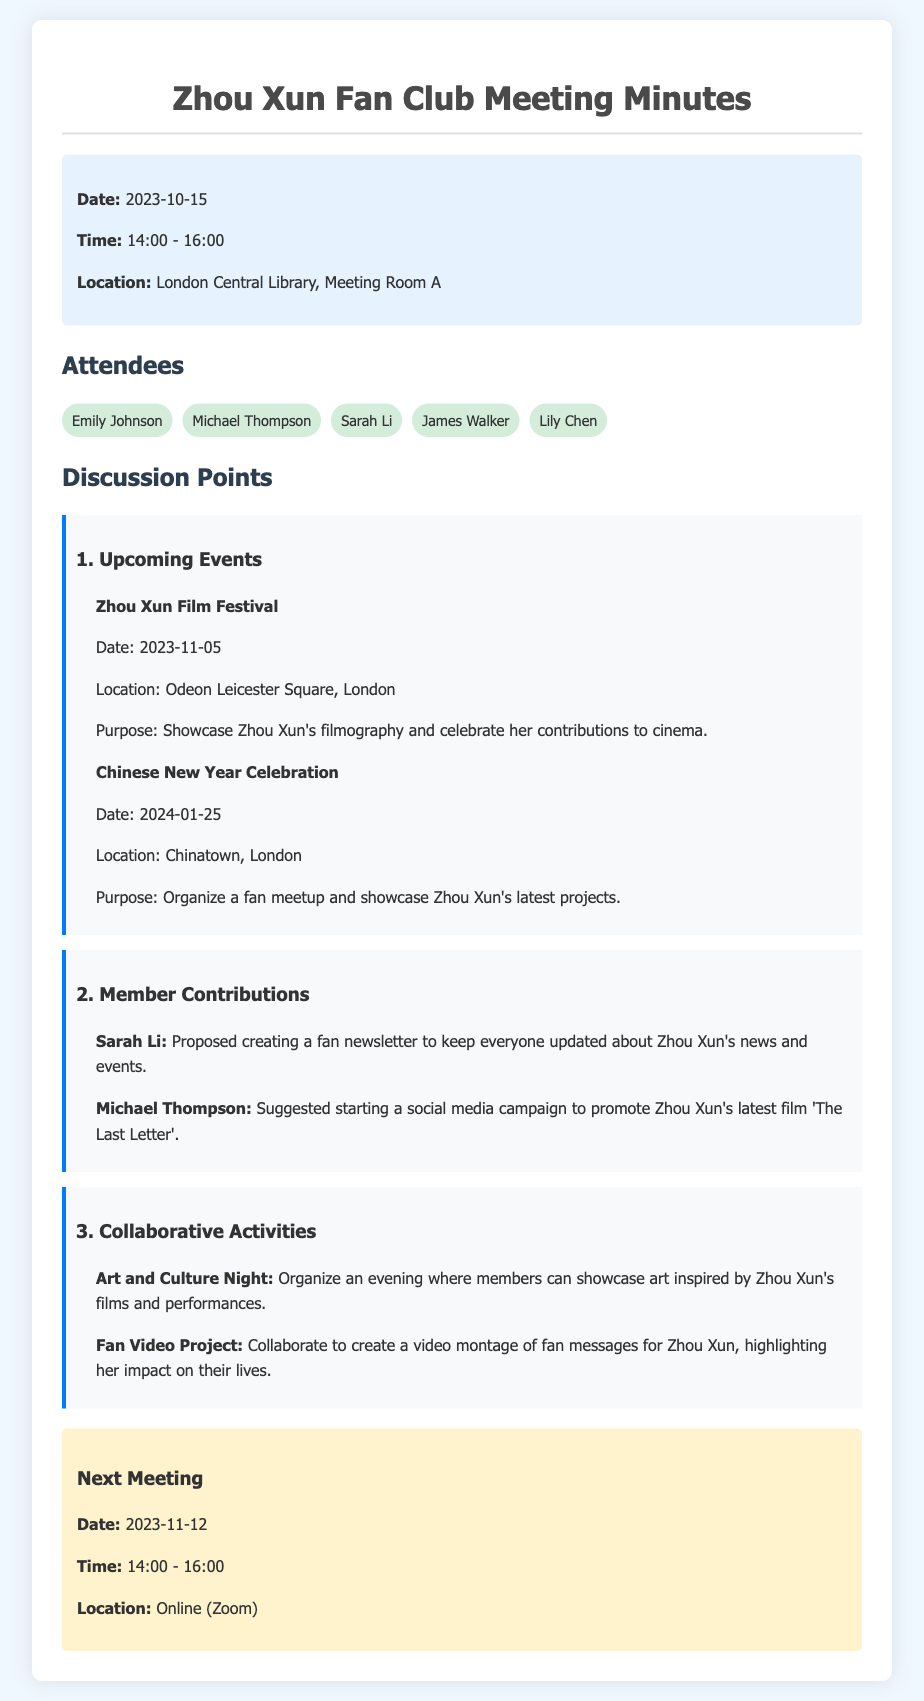what is the date of the Zhou Xun Film Festival? The date of the Zhou Xun Film Festival is mentioned as 2023-11-05 in the document.
Answer: 2023-11-05 where is the next meeting scheduled to take place? The location of the next meeting, which is on 2023-11-12, is specified as Online (Zoom).
Answer: Online (Zoom) who proposed creating a fan newsletter? The document states that Sarah Li proposed creating a fan newsletter.
Answer: Sarah Li what collaborative activity is about creating a video montage? The activity that involves creating a video montage is called the Fan Video Project, as mentioned in the discussion points.
Answer: Fan Video Project how many attendees were present at the meeting? The document lists five attendees present at the meeting.
Answer: 5 what is the purpose of the Chinese New Year Celebration? The purpose of the Chinese New Year Celebration is to organize a fan meetup and showcase Zhou Xun’s latest projects.
Answer: Organize a fan meetup and showcase Zhou Xun’s latest projects which member suggested a social media campaign? The document indicates that Michael Thompson suggested starting a social media campaign.
Answer: Michael Thompson when is the Chinese New Year Celebration scheduled? The Chinese New Year Celebration is scheduled for 2024-01-25, according to the document.
Answer: 2024-01-25 